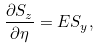<formula> <loc_0><loc_0><loc_500><loc_500>\frac { \partial S _ { z } } { \partial \eta } = E S _ { y } ,</formula> 